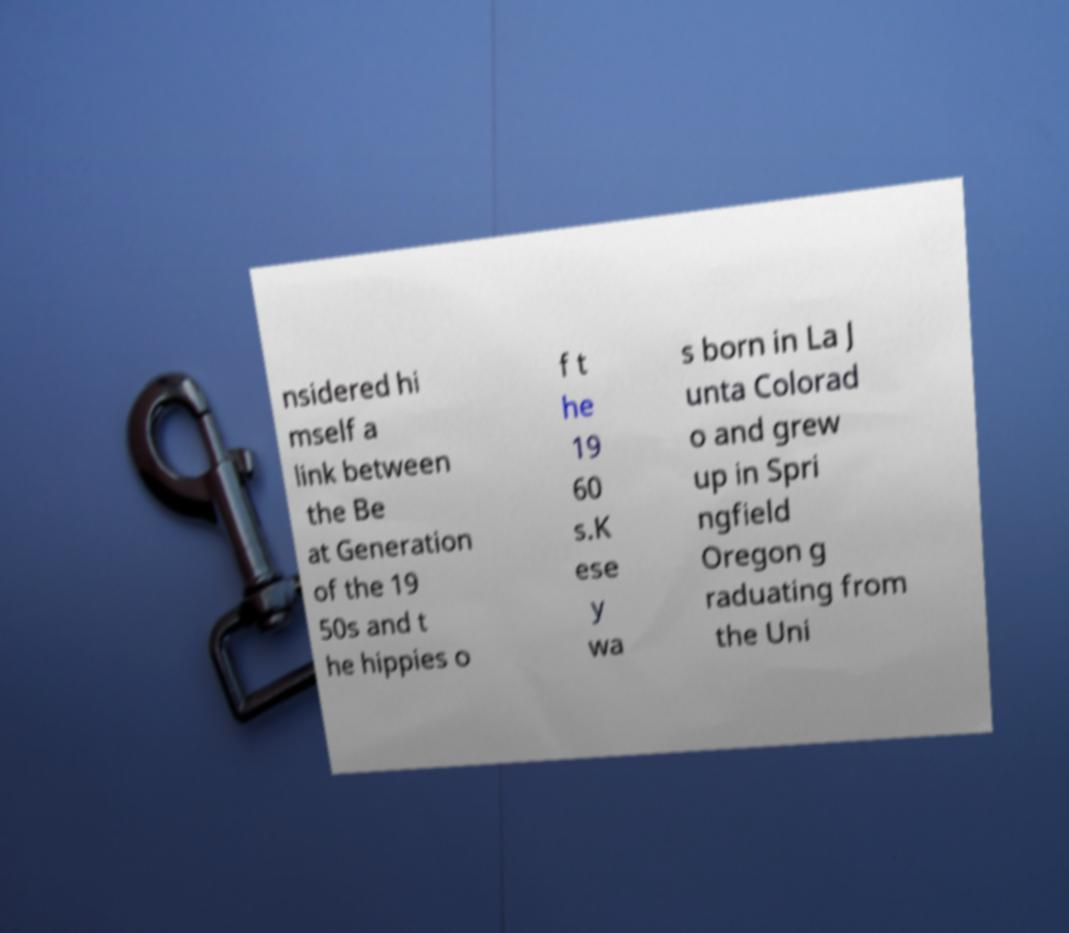I need the written content from this picture converted into text. Can you do that? nsidered hi mself a link between the Be at Generation of the 19 50s and t he hippies o f t he 19 60 s.K ese y wa s born in La J unta Colorad o and grew up in Spri ngfield Oregon g raduating from the Uni 